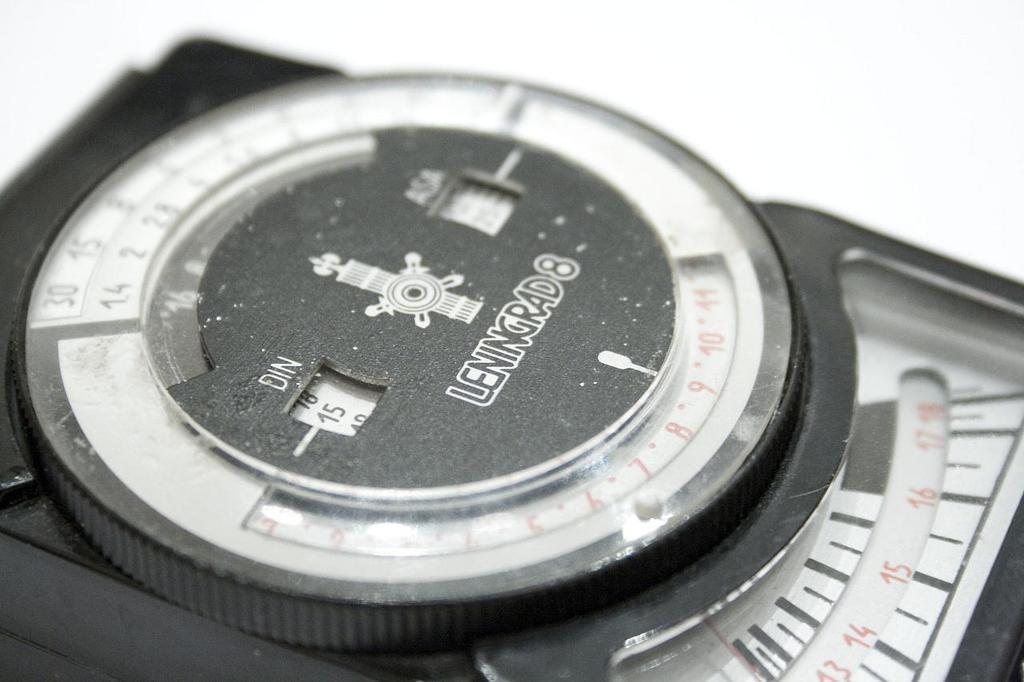<image>
Create a compact narrative representing the image presented. A black device has the brand name Leningrad 8 on it. 